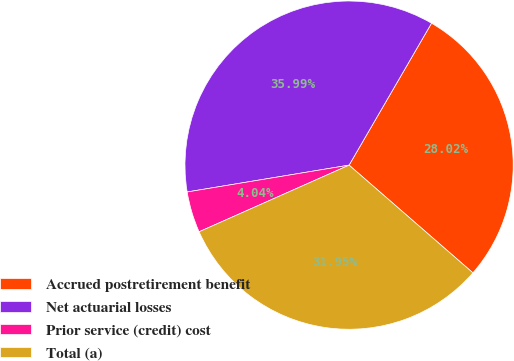Convert chart. <chart><loc_0><loc_0><loc_500><loc_500><pie_chart><fcel>Accrued postretirement benefit<fcel>Net actuarial losses<fcel>Prior service (credit) cost<fcel>Total (a)<nl><fcel>28.02%<fcel>35.99%<fcel>4.04%<fcel>31.95%<nl></chart> 